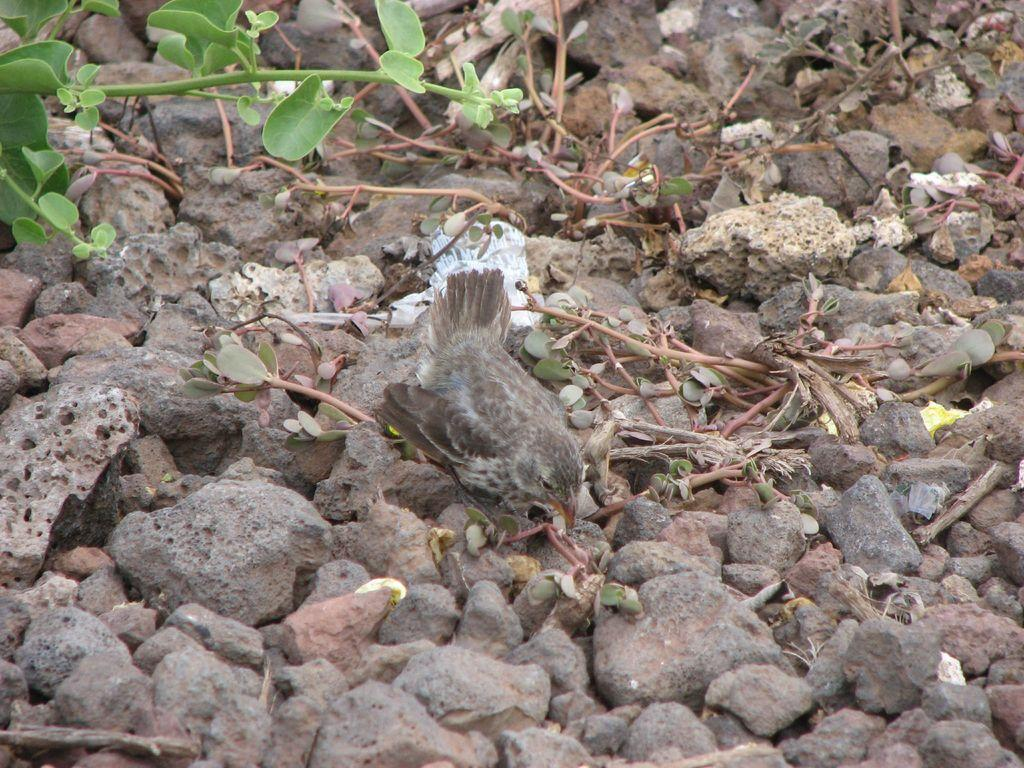What type of animal can be seen in the image? There is a bird in the image. What other objects are present in the image besides the bird? There are stones and leaves in the image. Can you hear the fish laughing in the image? There are no fish or sounds of laughter present in the image. 